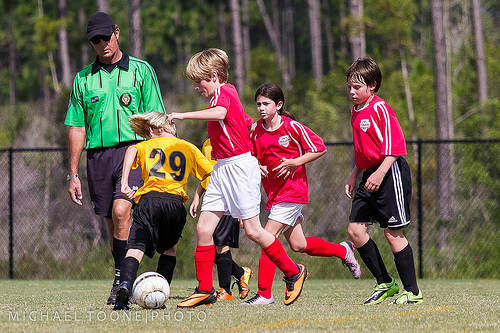<image>
Can you confirm if the boy is on the football? No. The boy is not positioned on the football. They may be near each other, but the boy is not supported by or resting on top of the football. 